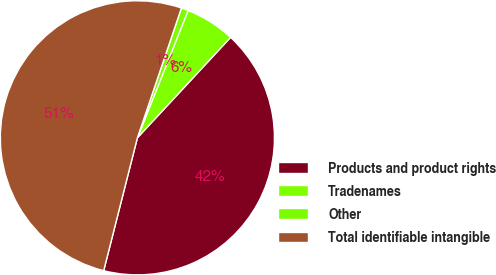Convert chart. <chart><loc_0><loc_0><loc_500><loc_500><pie_chart><fcel>Products and product rights<fcel>Tradenames<fcel>Other<fcel>Total identifiable intangible<nl><fcel>42.05%<fcel>5.87%<fcel>0.83%<fcel>51.25%<nl></chart> 